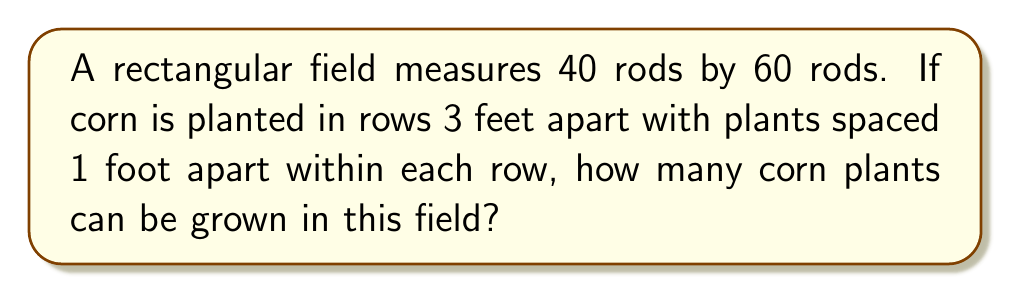Can you solve this math problem? Let's approach this step-by-step:

1) First, we need to convert the field dimensions from rods to feet:
   1 rod = 16.5 feet
   Field length = 60 rods = 60 * 16.5 = 990 feet
   Field width = 40 rods = 40 * 16.5 = 660 feet

2) Calculate the total area of the field in square feet:
   Area = length * width
   $$ A = 990 \text{ ft} \times 660 \text{ ft} = 653,400 \text{ sq ft} $$

3) Now, let's consider the plant spacing:
   - Rows are 3 feet apart
   - Plants within each row are 1 foot apart

4) Calculate the number of rows:
   $$ \text{Number of rows} = \frac{\text{Field width}}{\text{Row spacing}} = \frac{660 \text{ ft}}{3 \text{ ft}} = 220 \text{ rows} $$

5) Calculate the number of plants in each row:
   $$ \text{Plants per row} = \frac{\text{Field length}}{\text{Plant spacing}} = \frac{990 \text{ ft}}{1 \text{ ft}} = 990 \text{ plants} $$

6) Calculate the total number of plants:
   $$ \text{Total plants} = \text{Number of rows} \times \text{Plants per row} $$
   $$ \text{Total plants} = 220 \times 990 = 217,800 \text{ plants} $$

Therefore, 217,800 corn plants can be grown in this field.
Answer: 217,800 plants 